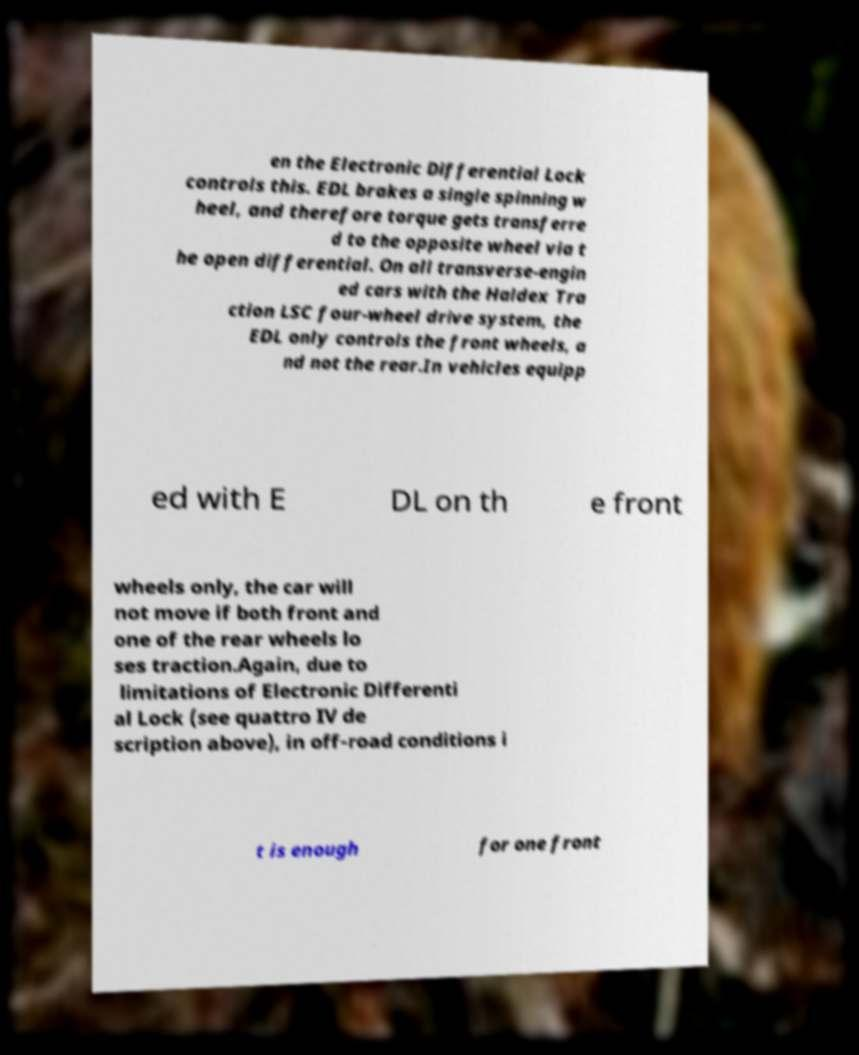Could you extract and type out the text from this image? en the Electronic Differential Lock controls this. EDL brakes a single spinning w heel, and therefore torque gets transferre d to the opposite wheel via t he open differential. On all transverse-engin ed cars with the Haldex Tra ction LSC four-wheel drive system, the EDL only controls the front wheels, a nd not the rear.In vehicles equipp ed with E DL on th e front wheels only, the car will not move if both front and one of the rear wheels lo ses traction.Again, due to limitations of Electronic Differenti al Lock (see quattro IV de scription above), in off-road conditions i t is enough for one front 